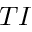<formula> <loc_0><loc_0><loc_500><loc_500>T I</formula> 